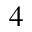Convert formula to latex. <formula><loc_0><loc_0><loc_500><loc_500>_ { 4 }</formula> 